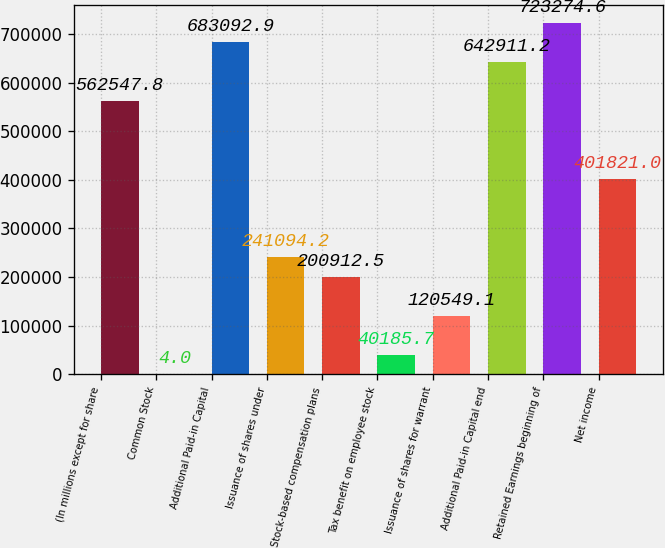Convert chart. <chart><loc_0><loc_0><loc_500><loc_500><bar_chart><fcel>(In millions except for share<fcel>Common Stock<fcel>Additional Paid-in Capital<fcel>Issuance of shares under<fcel>Stock-based compensation plans<fcel>Tax benefit on employee stock<fcel>Issuance of shares for warrant<fcel>Additional Paid-in Capital end<fcel>Retained Earnings beginning of<fcel>Net income<nl><fcel>562548<fcel>4<fcel>683093<fcel>241094<fcel>200912<fcel>40185.7<fcel>120549<fcel>642911<fcel>723275<fcel>401821<nl></chart> 